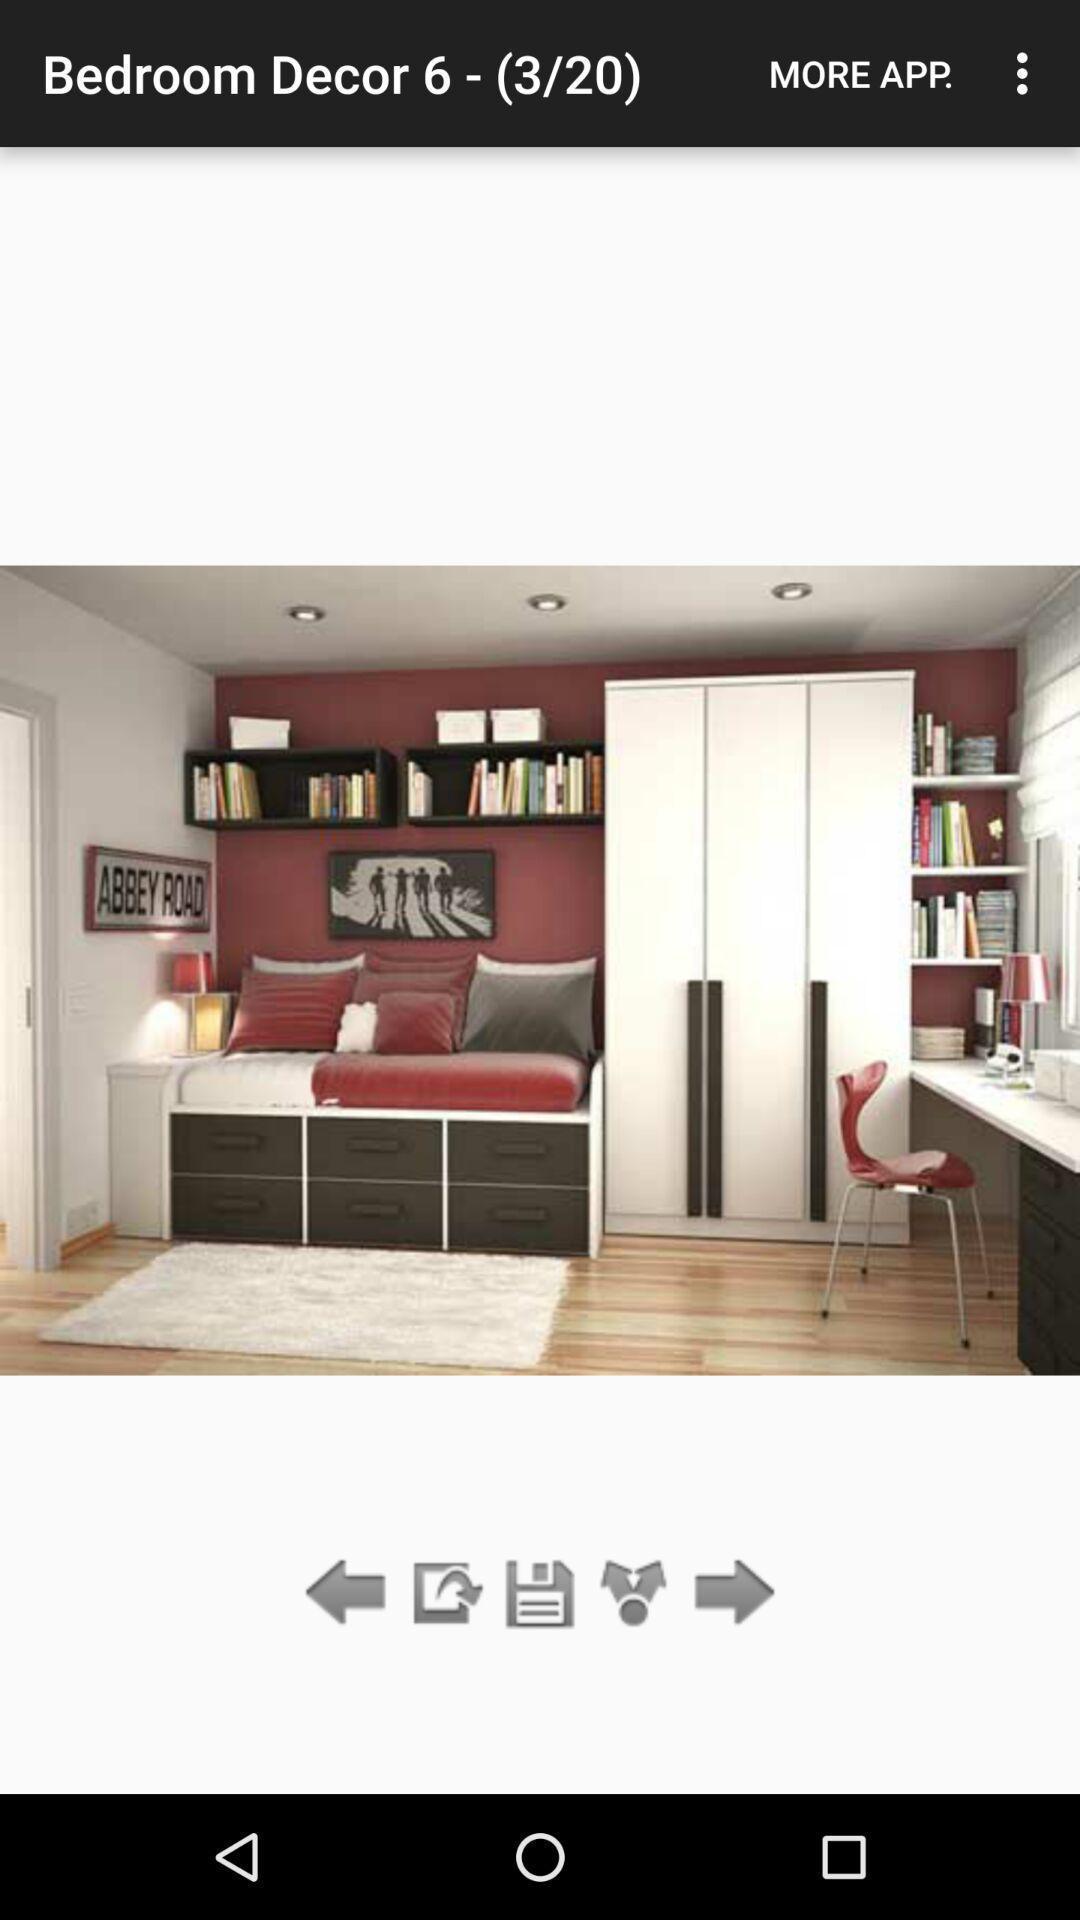Describe the content in this image. Page shows an image for bedroom decor. 